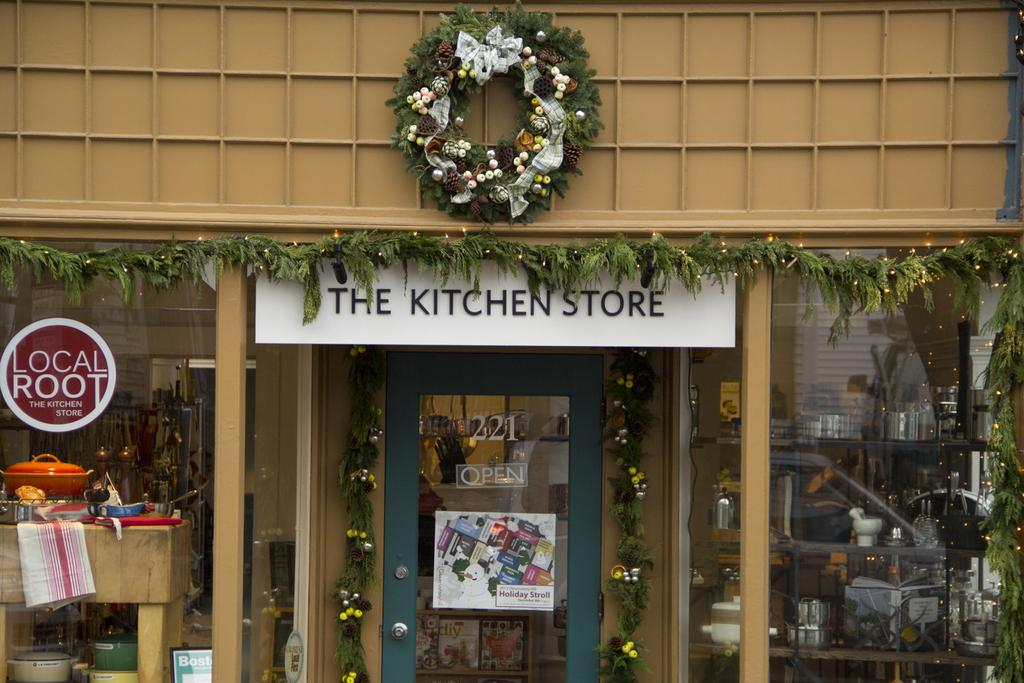<image>
Render a clear and concise summary of the photo. The kitchen store shown sells various items for the home. 